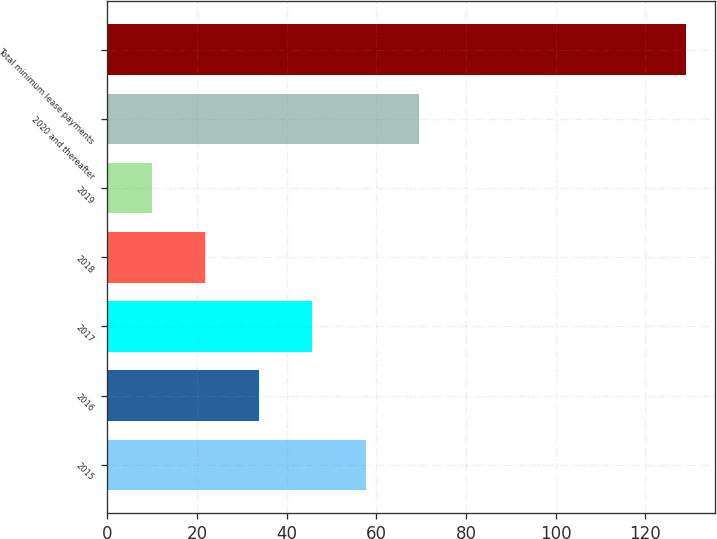Convert chart. <chart><loc_0><loc_0><loc_500><loc_500><bar_chart><fcel>2015<fcel>2016<fcel>2017<fcel>2018<fcel>2019<fcel>2020 and thereafter<fcel>Total minimum lease payments<nl><fcel>57.6<fcel>33.8<fcel>45.7<fcel>21.9<fcel>10<fcel>69.5<fcel>129<nl></chart> 